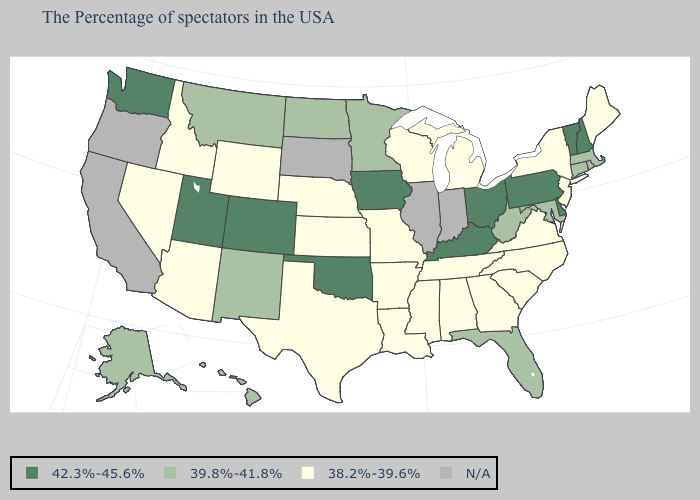What is the lowest value in the USA?
Quick response, please. 38.2%-39.6%. What is the lowest value in the MidWest?
Write a very short answer. 38.2%-39.6%. Among the states that border Vermont , does Massachusetts have the highest value?
Write a very short answer. No. What is the value of Alabama?
Answer briefly. 38.2%-39.6%. Name the states that have a value in the range 42.3%-45.6%?
Give a very brief answer. New Hampshire, Vermont, Delaware, Pennsylvania, Ohio, Kentucky, Iowa, Oklahoma, Colorado, Utah, Washington. Name the states that have a value in the range 39.8%-41.8%?
Concise answer only. Massachusetts, Connecticut, Maryland, West Virginia, Florida, Minnesota, North Dakota, New Mexico, Montana, Alaska, Hawaii. Name the states that have a value in the range 42.3%-45.6%?
Quick response, please. New Hampshire, Vermont, Delaware, Pennsylvania, Ohio, Kentucky, Iowa, Oklahoma, Colorado, Utah, Washington. Name the states that have a value in the range 38.2%-39.6%?
Give a very brief answer. Maine, New York, New Jersey, Virginia, North Carolina, South Carolina, Georgia, Michigan, Alabama, Tennessee, Wisconsin, Mississippi, Louisiana, Missouri, Arkansas, Kansas, Nebraska, Texas, Wyoming, Arizona, Idaho, Nevada. What is the value of Missouri?
Quick response, please. 38.2%-39.6%. What is the highest value in states that border West Virginia?
Short answer required. 42.3%-45.6%. Name the states that have a value in the range 42.3%-45.6%?
Keep it brief. New Hampshire, Vermont, Delaware, Pennsylvania, Ohio, Kentucky, Iowa, Oklahoma, Colorado, Utah, Washington. What is the lowest value in the South?
Write a very short answer. 38.2%-39.6%. What is the highest value in the West ?
Give a very brief answer. 42.3%-45.6%. 